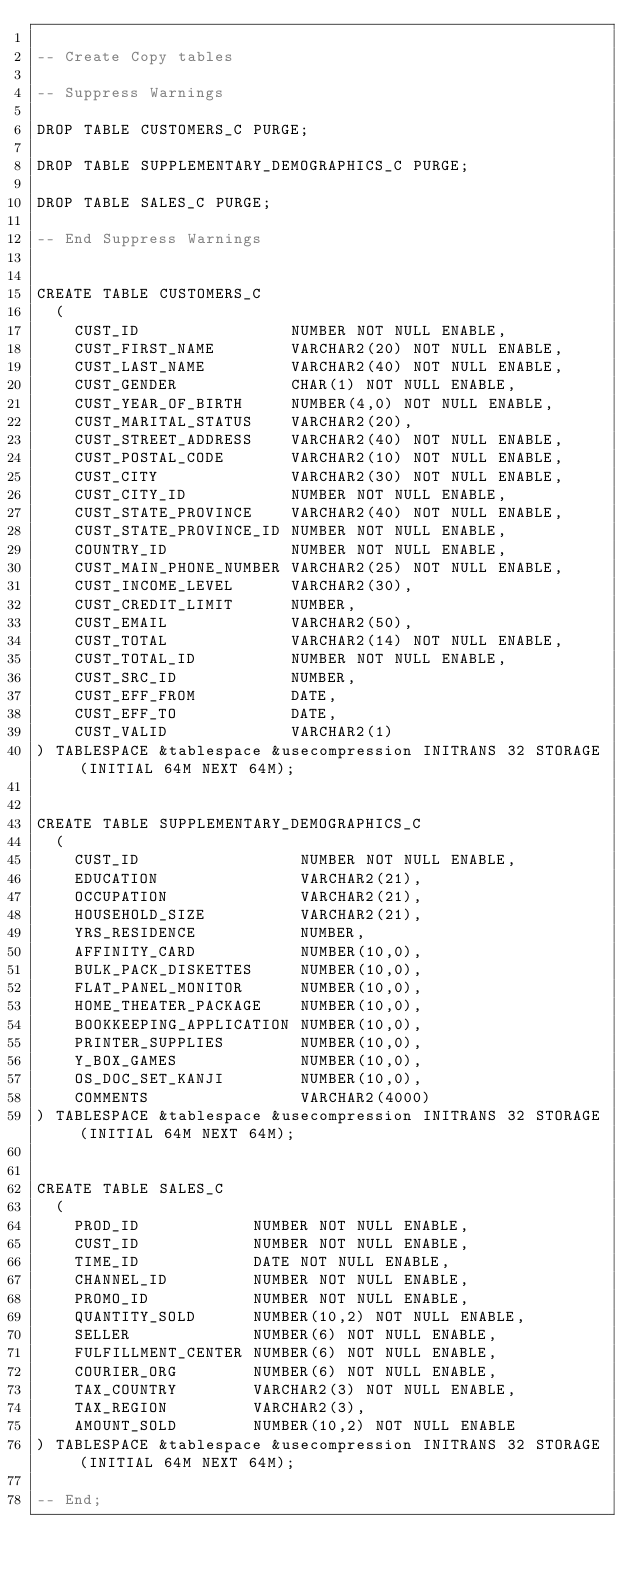<code> <loc_0><loc_0><loc_500><loc_500><_SQL_>
-- Create Copy tables

-- Suppress Warnings

DROP TABLE CUSTOMERS_C PURGE;

DROP TABLE SUPPLEMENTARY_DEMOGRAPHICS_C PURGE;

DROP TABLE SALES_C PURGE;

-- End Suppress Warnings


CREATE TABLE CUSTOMERS_C
  (
    CUST_ID                NUMBER NOT NULL ENABLE,
    CUST_FIRST_NAME        VARCHAR2(20) NOT NULL ENABLE,
    CUST_LAST_NAME         VARCHAR2(40) NOT NULL ENABLE,
    CUST_GENDER            CHAR(1) NOT NULL ENABLE,
    CUST_YEAR_OF_BIRTH     NUMBER(4,0) NOT NULL ENABLE,
    CUST_MARITAL_STATUS    VARCHAR2(20),
    CUST_STREET_ADDRESS    VARCHAR2(40) NOT NULL ENABLE,
    CUST_POSTAL_CODE       VARCHAR2(10) NOT NULL ENABLE,
    CUST_CITY              VARCHAR2(30) NOT NULL ENABLE,
    CUST_CITY_ID           NUMBER NOT NULL ENABLE,
    CUST_STATE_PROVINCE    VARCHAR2(40) NOT NULL ENABLE,
    CUST_STATE_PROVINCE_ID NUMBER NOT NULL ENABLE,
    COUNTRY_ID             NUMBER NOT NULL ENABLE,
    CUST_MAIN_PHONE_NUMBER VARCHAR2(25) NOT NULL ENABLE,
    CUST_INCOME_LEVEL      VARCHAR2(30),
    CUST_CREDIT_LIMIT      NUMBER,
    CUST_EMAIL             VARCHAR2(50),
    CUST_TOTAL             VARCHAR2(14) NOT NULL ENABLE,
    CUST_TOTAL_ID          NUMBER NOT NULL ENABLE,
    CUST_SRC_ID            NUMBER,
    CUST_EFF_FROM          DATE,
    CUST_EFF_TO            DATE,
    CUST_VALID             VARCHAR2(1)
) TABLESPACE &tablespace &usecompression INITRANS 32 STORAGE (INITIAL 64M NEXT 64M);


CREATE TABLE SUPPLEMENTARY_DEMOGRAPHICS_C
  (
    CUST_ID                 NUMBER NOT NULL ENABLE,
    EDUCATION               VARCHAR2(21),
    OCCUPATION              VARCHAR2(21),
    HOUSEHOLD_SIZE          VARCHAR2(21),
    YRS_RESIDENCE           NUMBER,
    AFFINITY_CARD           NUMBER(10,0),
    BULK_PACK_DISKETTES     NUMBER(10,0),
    FLAT_PANEL_MONITOR      NUMBER(10,0),
    HOME_THEATER_PACKAGE    NUMBER(10,0),
    BOOKKEEPING_APPLICATION NUMBER(10,0),
    PRINTER_SUPPLIES        NUMBER(10,0),
    Y_BOX_GAMES             NUMBER(10,0),
    OS_DOC_SET_KANJI        NUMBER(10,0),
    COMMENTS                VARCHAR2(4000)
) TABLESPACE &tablespace &usecompression INITRANS 32 STORAGE (INITIAL 64M NEXT 64M);


CREATE TABLE SALES_C
  (
    PROD_ID            NUMBER NOT NULL ENABLE,
    CUST_ID            NUMBER NOT NULL ENABLE,
    TIME_ID            DATE NOT NULL ENABLE,
    CHANNEL_ID         NUMBER NOT NULL ENABLE,
    PROMO_ID           NUMBER NOT NULL ENABLE,
    QUANTITY_SOLD      NUMBER(10,2) NOT NULL ENABLE,
    SELLER             NUMBER(6) NOT NULL ENABLE,
    FULFILLMENT_CENTER NUMBER(6) NOT NULL ENABLE,
    COURIER_ORG        NUMBER(6) NOT NULL ENABLE,
    TAX_COUNTRY        VARCHAR2(3) NOT NULL ENABLE,
    TAX_REGION         VARCHAR2(3),
    AMOUNT_SOLD        NUMBER(10,2) NOT NULL ENABLE
) TABLESPACE &tablespace &usecompression INITRANS 32 STORAGE (INITIAL 64M NEXT 64M); 

-- End;
 
</code> 